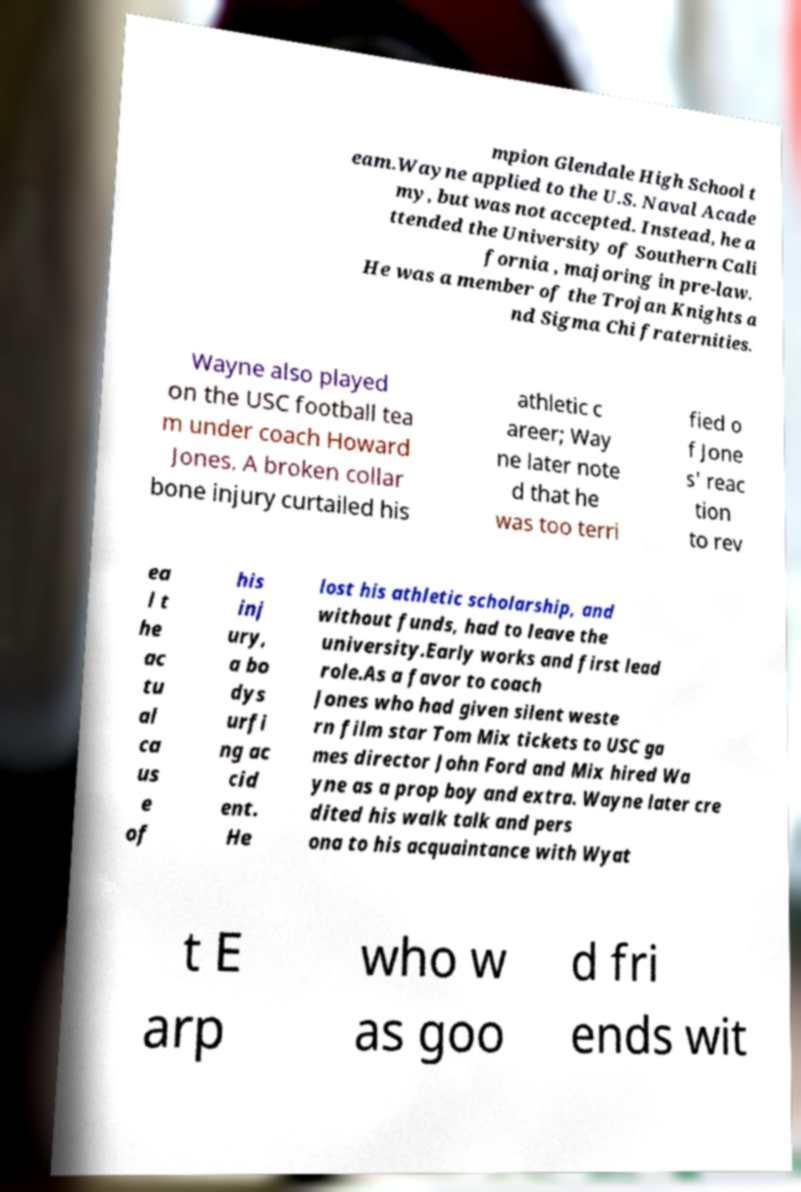Could you assist in decoding the text presented in this image and type it out clearly? mpion Glendale High School t eam.Wayne applied to the U.S. Naval Acade my, but was not accepted. Instead, he a ttended the University of Southern Cali fornia , majoring in pre-law. He was a member of the Trojan Knights a nd Sigma Chi fraternities. Wayne also played on the USC football tea m under coach Howard Jones. A broken collar bone injury curtailed his athletic c areer; Way ne later note d that he was too terri fied o f Jone s' reac tion to rev ea l t he ac tu al ca us e of his inj ury, a bo dys urfi ng ac cid ent. He lost his athletic scholarship, and without funds, had to leave the university.Early works and first lead role.As a favor to coach Jones who had given silent weste rn film star Tom Mix tickets to USC ga mes director John Ford and Mix hired Wa yne as a prop boy and extra. Wayne later cre dited his walk talk and pers ona to his acquaintance with Wyat t E arp who w as goo d fri ends wit 